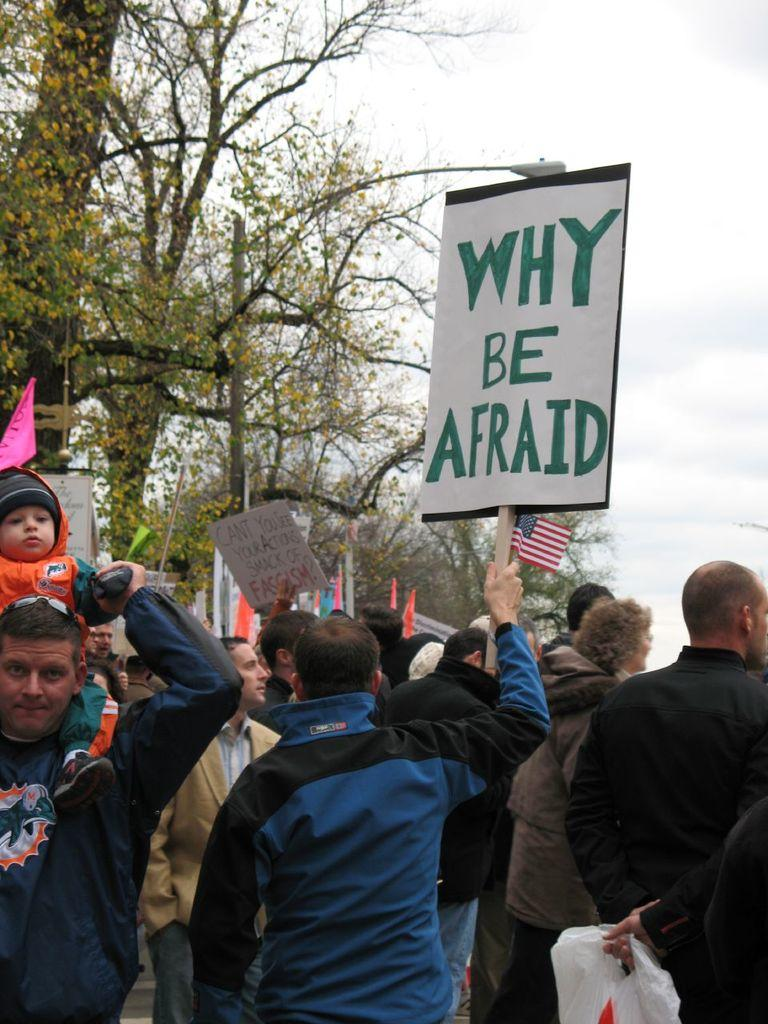<image>
Render a clear and concise summary of the photo. A group of protesters are shown and one of them has a sign that says Why Be Afraid. 